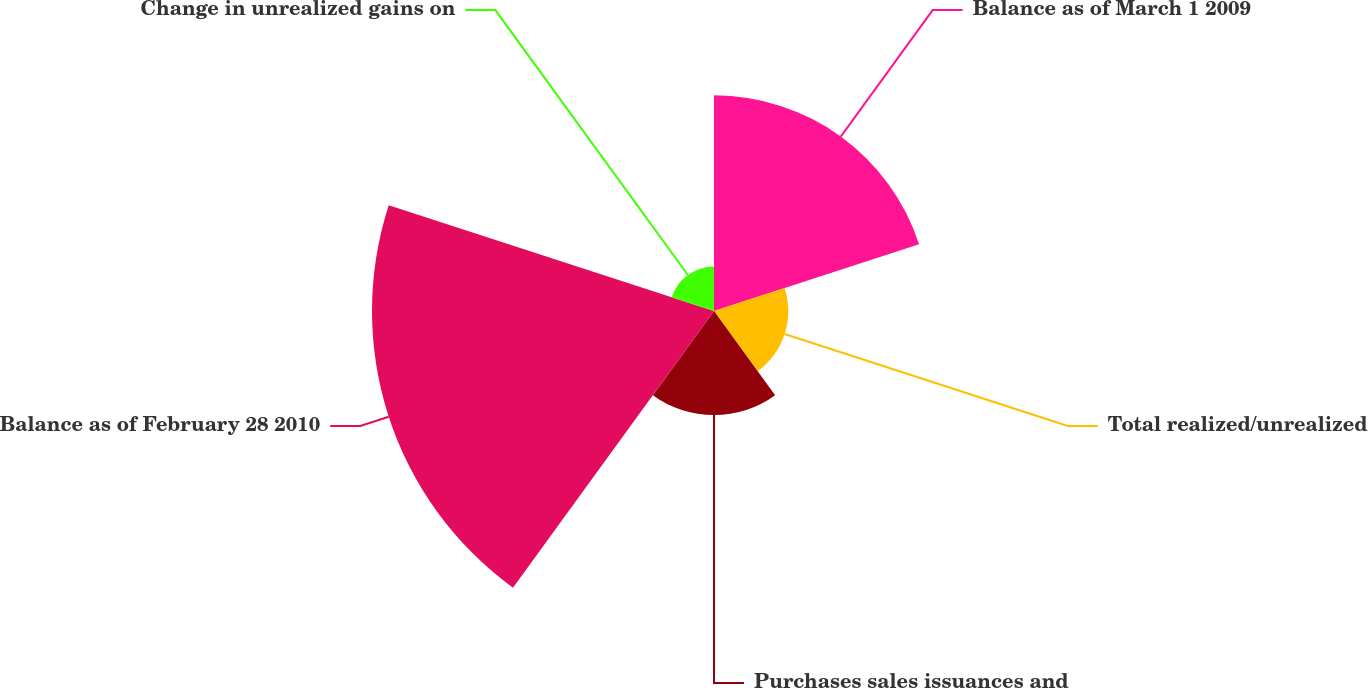Convert chart to OTSL. <chart><loc_0><loc_0><loc_500><loc_500><pie_chart><fcel>Balance as of March 1 2009<fcel>Total realized/unrealized<fcel>Purchases sales issuances and<fcel>Balance as of February 28 2010<fcel>Change in unrealized gains on<nl><fcel>27.63%<fcel>9.52%<fcel>13.33%<fcel>43.82%<fcel>5.7%<nl></chart> 